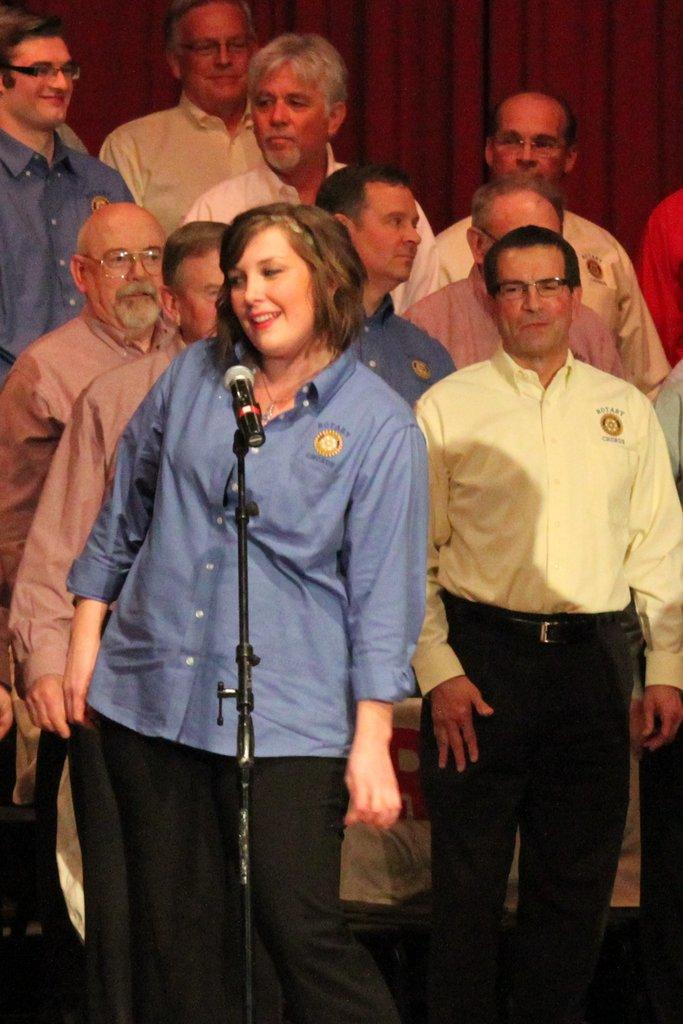What is the woman in the image doing? The woman is standing in the image. What object is in front of the woman? There is a mic in front of the woman. What can be seen behind the woman? There is a group of men behind the woman. What is visible in the background of the image? There is a curtain in the background of the image. What color is the crayon being used by the passenger in the image? There is no crayon or passenger present in the image. 